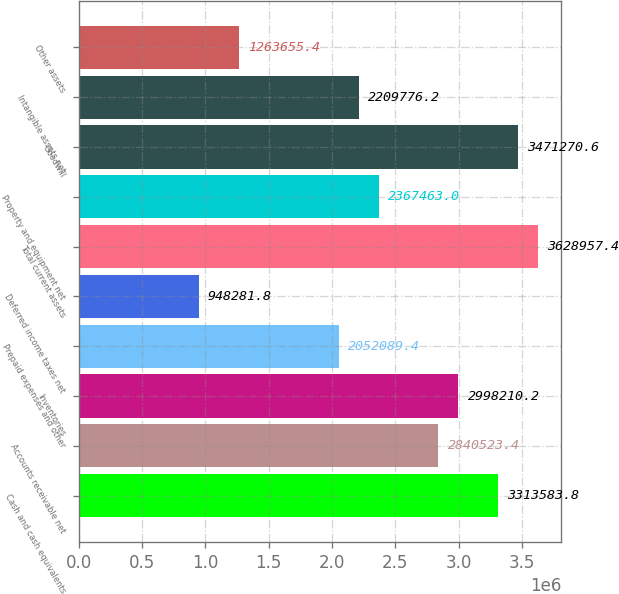Convert chart. <chart><loc_0><loc_0><loc_500><loc_500><bar_chart><fcel>Cash and cash equivalents<fcel>Accounts receivable net<fcel>Inventories<fcel>Prepaid expenses and other<fcel>Deferred income taxes net<fcel>Total current assets<fcel>Property and equipment net<fcel>Goodwill<fcel>Intangible assets net<fcel>Other assets<nl><fcel>3.31358e+06<fcel>2.84052e+06<fcel>2.99821e+06<fcel>2.05209e+06<fcel>948282<fcel>3.62896e+06<fcel>2.36746e+06<fcel>3.47127e+06<fcel>2.20978e+06<fcel>1.26366e+06<nl></chart> 